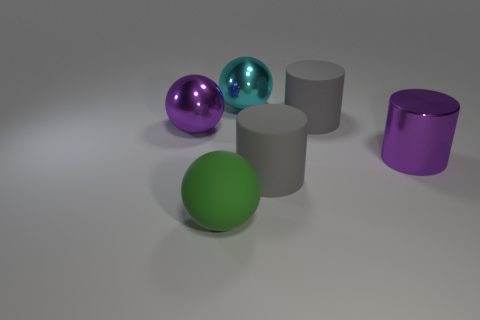Is there any other thing that is made of the same material as the large cyan object?
Offer a terse response. Yes. How many rubber objects are big gray cylinders or cylinders?
Your answer should be compact. 2. What material is the big green ball?
Give a very brief answer. Rubber. There is a rubber sphere; how many purple cylinders are behind it?
Make the answer very short. 1. Is the object left of the large green sphere made of the same material as the green sphere?
Your answer should be very brief. No. What number of matte things are the same shape as the large cyan shiny object?
Keep it short and to the point. 1. How many tiny things are red metallic cylinders or metal cylinders?
Give a very brief answer. 0. There is a large metal object to the left of the large cyan ball; is its color the same as the metal cylinder?
Your answer should be very brief. Yes. Is the color of the matte thing that is behind the large purple shiny ball the same as the big rubber cylinder that is in front of the purple metallic ball?
Keep it short and to the point. Yes. Are there any objects that have the same material as the large purple cylinder?
Your answer should be compact. Yes. 